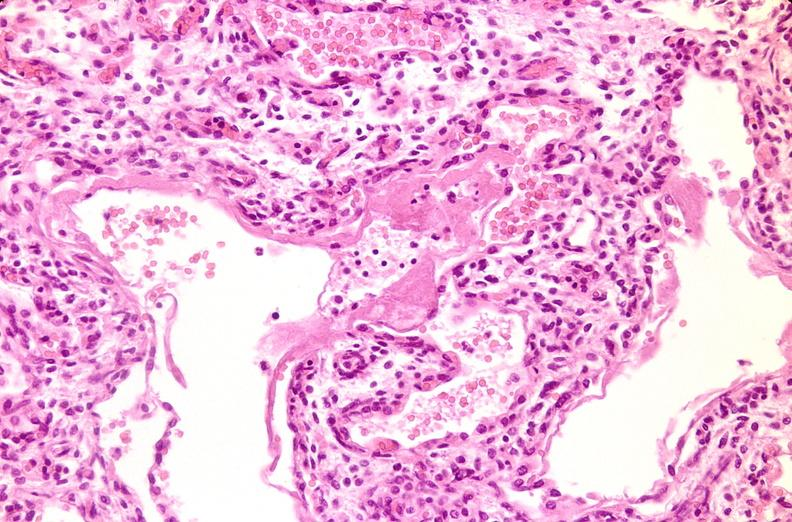s di george syndrome present?
Answer the question using a single word or phrase. No 